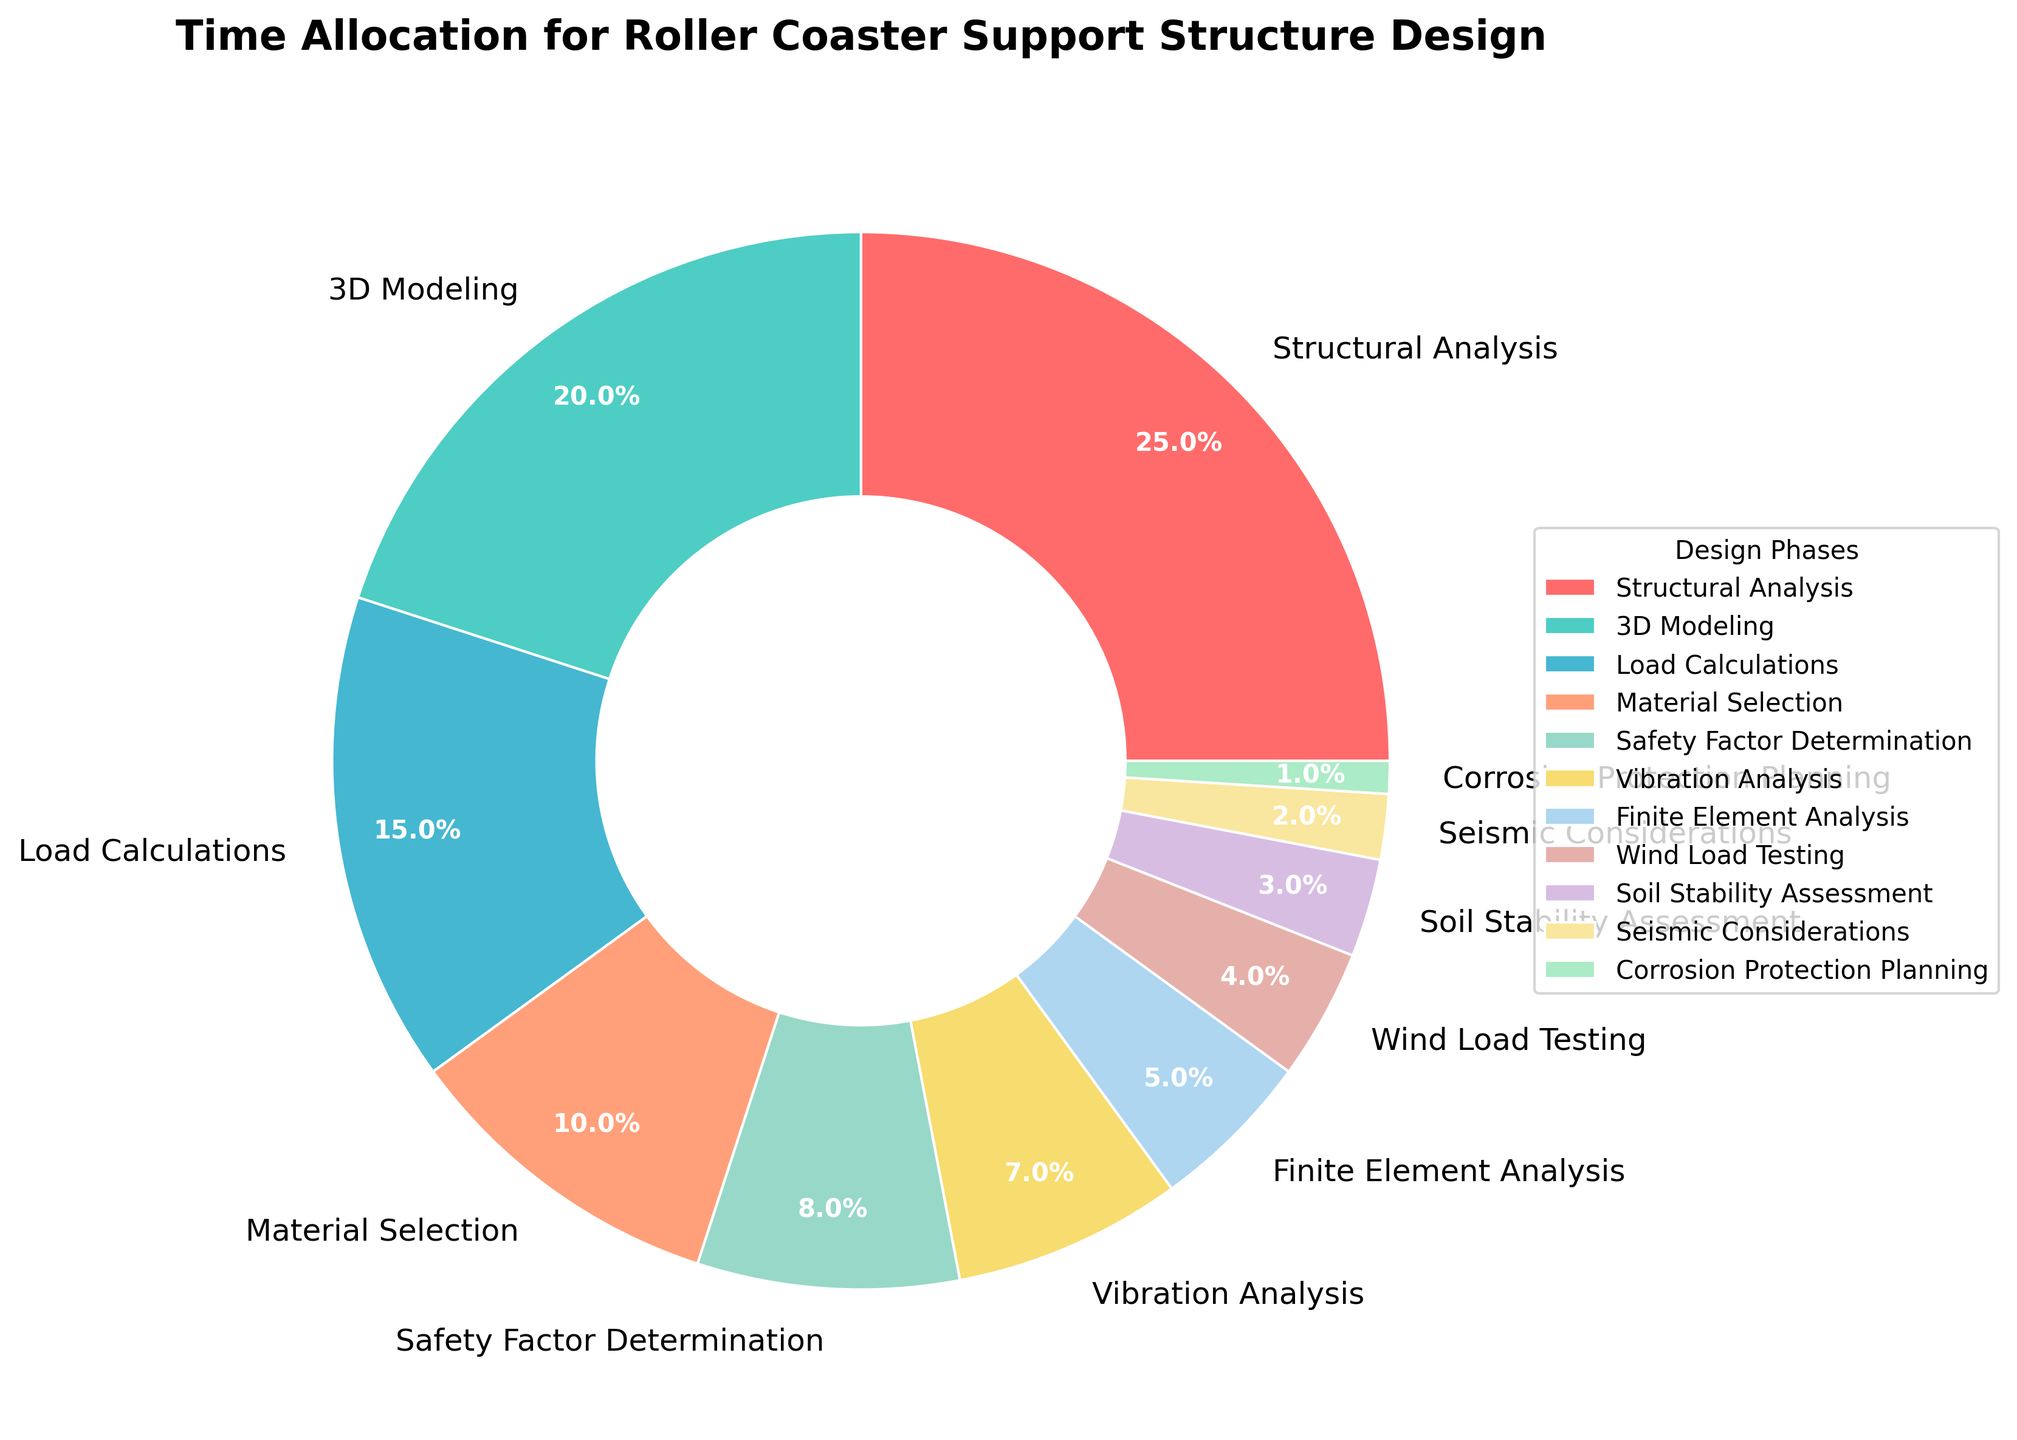Which phase allocates the highest percentage of time? The phase with the highest percentage allocation on the pie chart is Structural Analysis at 25%.
Answer: Structural Analysis Which two phases combined take up the most time? By examining the pie chart, the two phases with the highest allocations are Structural Analysis (25%) and 3D Modeling (20%). Together, they total 45%.
Answer: Structural Analysis and 3D Modeling How much more time is spent on Structural Analysis compared to Seismic Considerations? Structural Analysis takes 25%, and Seismic Considerations takes 2%. Subtracting the two: 25% - 2% = 23%.
Answer: 23% Which phases have allocations less than 5%? The pie chart shows the phases with less than 5% allocation are Wind Load Testing (4%), Soil Stability Assessment (3%), Seismic Considerations (2%), and Corrosion Protection Planning (1%).
Answer: Wind Load Testing, Soil Stability Assessment, Seismic Considerations, Corrosion Protection Planning What is the combined percentage of time spent on Safety Factor Determination and Vibration Analysis? Safety Factor Determination takes 8%, and Vibration Analysis takes 7%. Adding them up: 8% + 7% = 15%.
Answer: 15% Is more time spent on Finite Element Analysis or on Load Calculations? The pie chart shows Finite Element Analysis at 5% and Load Calculations at 15%. Therefore, more time is spent on Load Calculations.
Answer: Load Calculations Which color wedge represents the phase with the least time allocation? The phase with the least time allocation is Corrosion Protection Planning at 1%, and its corresponding color wedge is identified as the mint-green colored portion.
Answer: mint-green Calculate the average percentage allocation for the phases with the three lowest time allocations. The phases with the lowest allocations are Corrosion Protection Planning (1%), Seismic Considerations (2%), and Soil Stability Assessment (3%). The average is (1% + 2% + 3%) / 3 = 2%.
Answer: 2% What is the difference in time allocation between Material Selection and Safety Factor Determination? Material Selection is allocated 10% and Safety Factor Determination 8%. The difference is 10% - 8% = 2%.
Answer: 2% If the time allocated to 3D Modeling were doubled, what would be the new total percentage allocation for 3D Modeling? Currently, 3D Modeling is allocated 20%. Doubling this would result in 20% * 2 = 40%.
Answer: 40% 